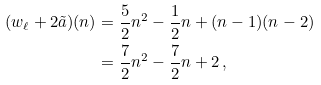Convert formula to latex. <formula><loc_0><loc_0><loc_500><loc_500>( w _ { \ell } + 2 \tilde { a } ) ( n ) & = \frac { 5 } { 2 } n ^ { 2 } - \frac { 1 } { 2 } n + ( n - 1 ) ( n - 2 ) \\ & = \frac { 7 } { 2 } n ^ { 2 } - \frac { 7 } { 2 } n + 2 \, ,</formula> 